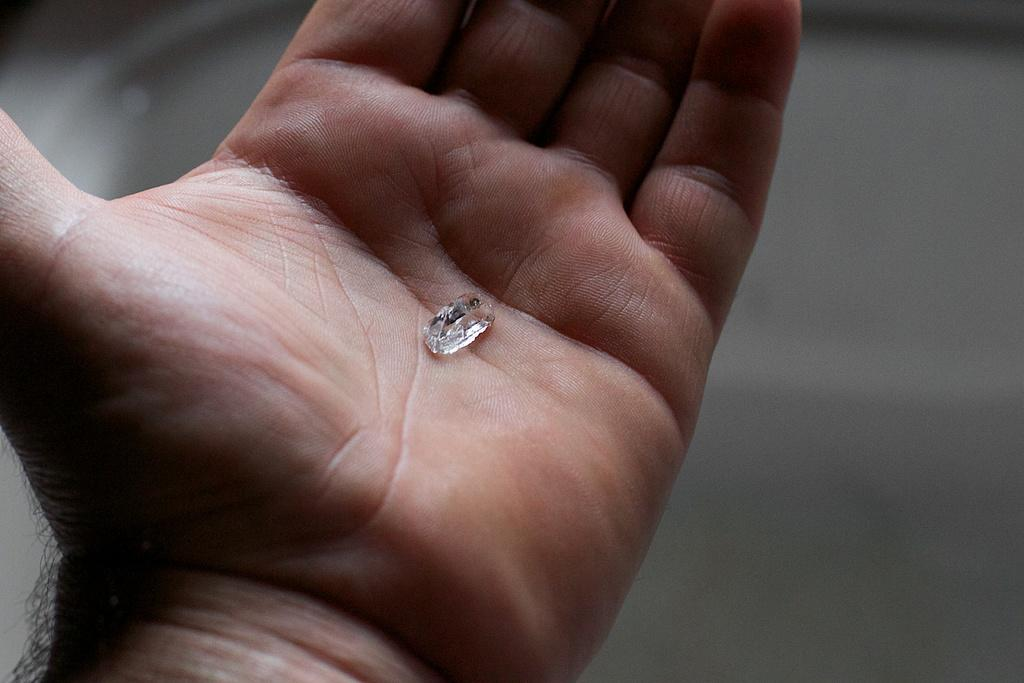What is the small white object in the image? There is a small white object on a hand in the image. How many bikes are visible in the image? There are no bikes present in the image. What emotion does the person holding the small white object feel in the image? The provided facts do not give any information about the emotions of the person holding the small white object. Is there a plane visible in the image? There is no plane present in the image. 